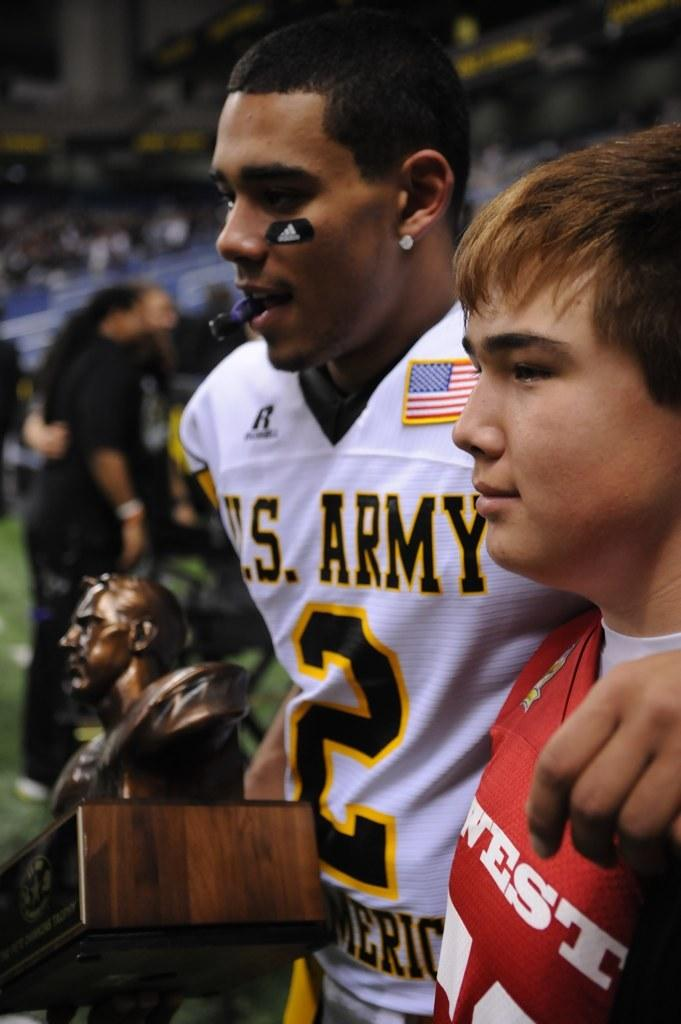<image>
Present a compact description of the photo's key features. a player that has the number 2 on their jersey 